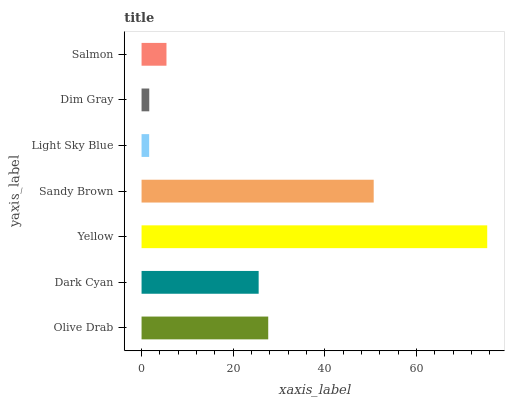Is Light Sky Blue the minimum?
Answer yes or no. Yes. Is Yellow the maximum?
Answer yes or no. Yes. Is Dark Cyan the minimum?
Answer yes or no. No. Is Dark Cyan the maximum?
Answer yes or no. No. Is Olive Drab greater than Dark Cyan?
Answer yes or no. Yes. Is Dark Cyan less than Olive Drab?
Answer yes or no. Yes. Is Dark Cyan greater than Olive Drab?
Answer yes or no. No. Is Olive Drab less than Dark Cyan?
Answer yes or no. No. Is Dark Cyan the high median?
Answer yes or no. Yes. Is Dark Cyan the low median?
Answer yes or no. Yes. Is Light Sky Blue the high median?
Answer yes or no. No. Is Light Sky Blue the low median?
Answer yes or no. No. 